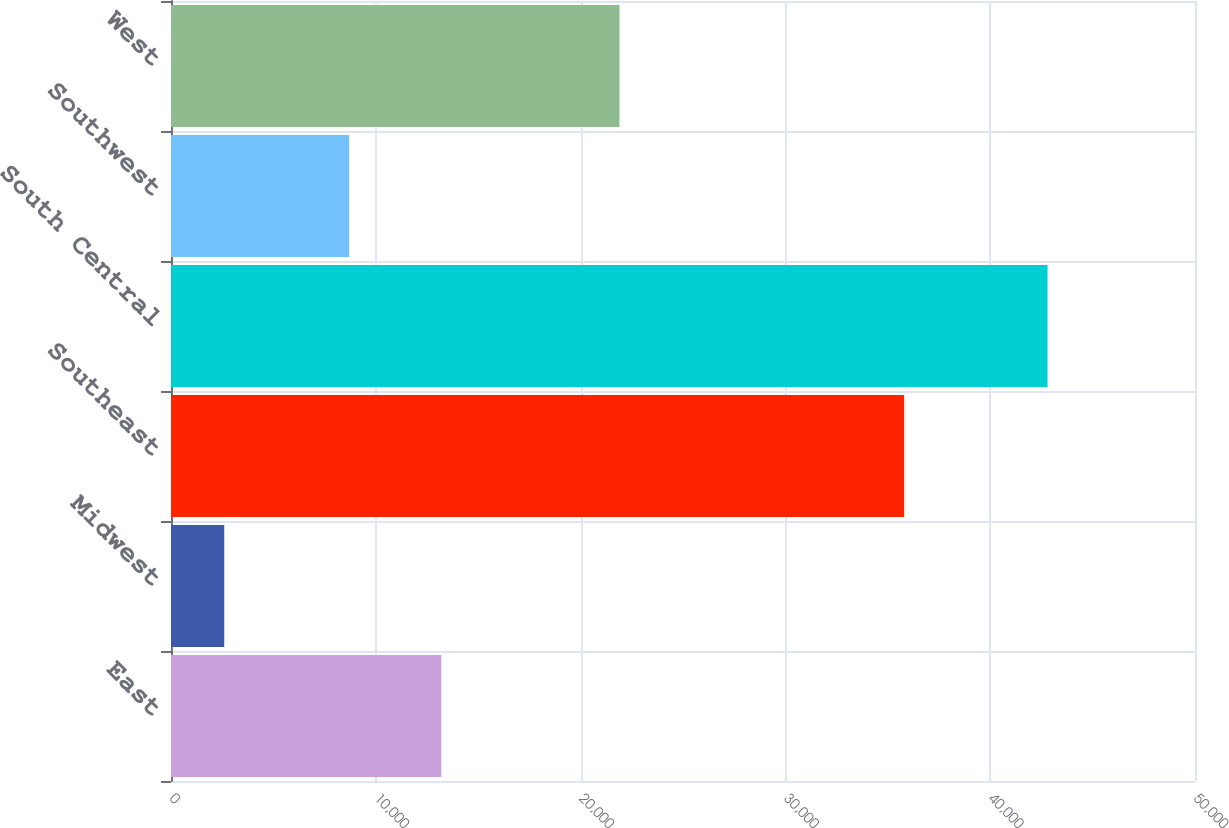Convert chart to OTSL. <chart><loc_0><loc_0><loc_500><loc_500><bar_chart><fcel>East<fcel>Midwest<fcel>Southeast<fcel>South Central<fcel>Southwest<fcel>West<nl><fcel>13200<fcel>2600<fcel>35800<fcel>42800<fcel>8700<fcel>21900<nl></chart> 